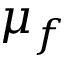<formula> <loc_0><loc_0><loc_500><loc_500>\mu _ { f }</formula> 